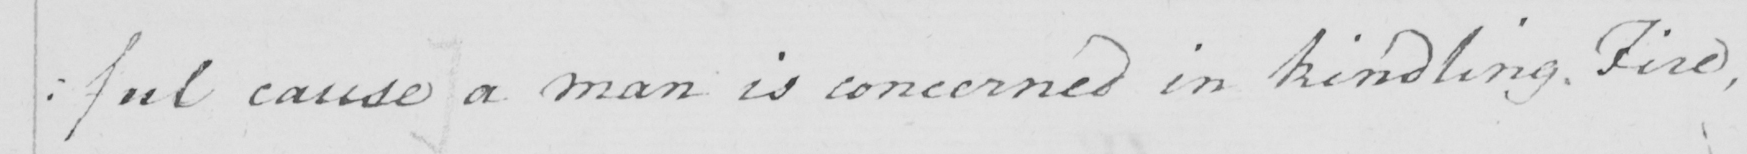Please transcribe the handwritten text in this image. :  : ful cause ]  a man is concerned in kindling Fire , 